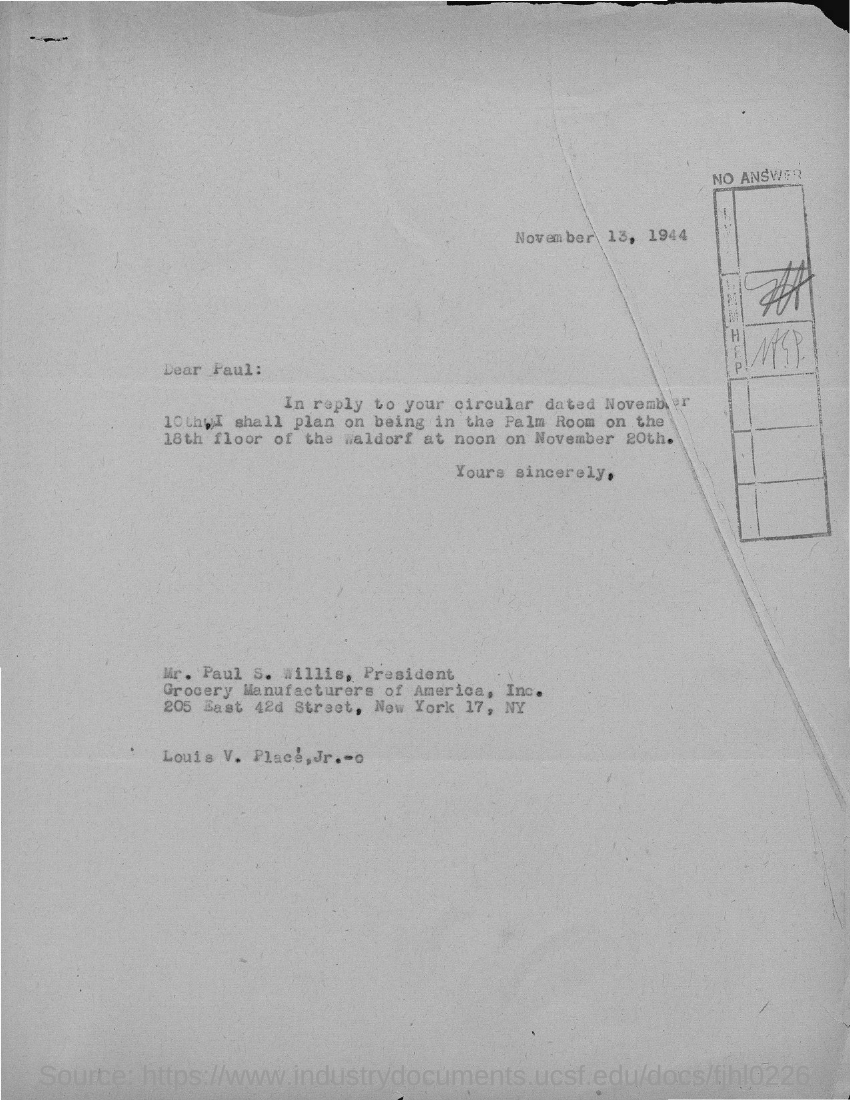Indicate a few pertinent items in this graphic. The document provides the information that the date mentioned at the top of the document is November 13, 1944. 